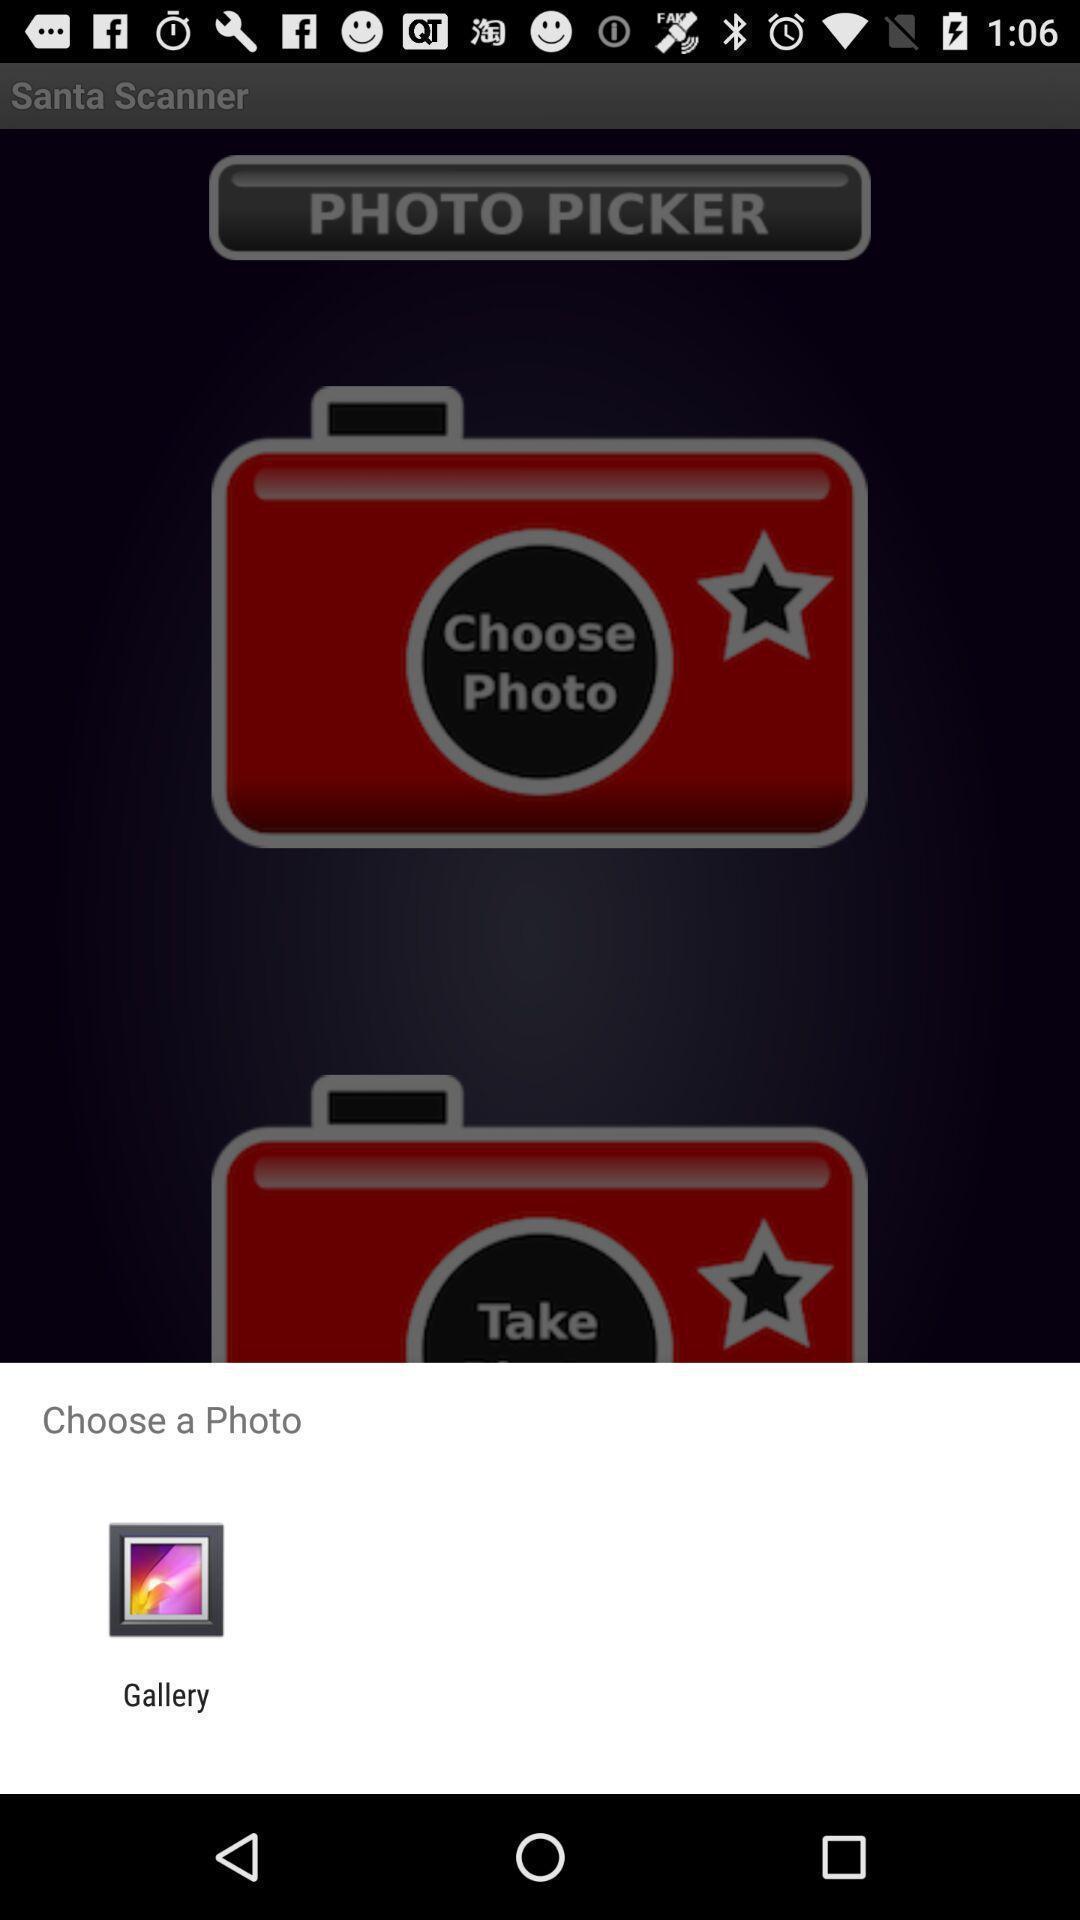What can you discern from this picture? Popup showing about gallery option. 